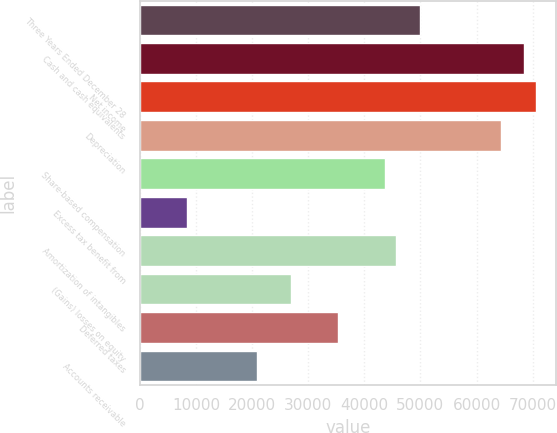Convert chart to OTSL. <chart><loc_0><loc_0><loc_500><loc_500><bar_chart><fcel>Three Years Ended December 28<fcel>Cash and cash equivalents<fcel>Net income<fcel>Depreciation<fcel>Share-based compensation<fcel>Excess tax benefit from<fcel>Amortization of intangibles<fcel>(Gains) losses on equity<fcel>Deferred taxes<fcel>Accounts receivable<nl><fcel>49849.8<fcel>68540.1<fcel>70616.8<fcel>64386.7<fcel>43619.7<fcel>8315.8<fcel>45696.4<fcel>27006.1<fcel>35312.9<fcel>20776<nl></chart> 